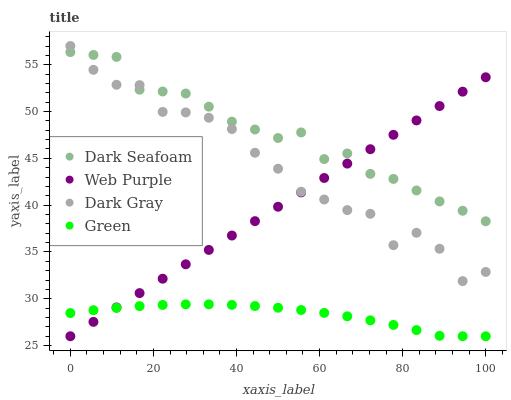Does Green have the minimum area under the curve?
Answer yes or no. Yes. Does Dark Seafoam have the maximum area under the curve?
Answer yes or no. Yes. Does Dark Seafoam have the minimum area under the curve?
Answer yes or no. No. Does Green have the maximum area under the curve?
Answer yes or no. No. Is Web Purple the smoothest?
Answer yes or no. Yes. Is Dark Gray the roughest?
Answer yes or no. Yes. Is Dark Seafoam the smoothest?
Answer yes or no. No. Is Dark Seafoam the roughest?
Answer yes or no. No. Does Green have the lowest value?
Answer yes or no. Yes. Does Dark Seafoam have the lowest value?
Answer yes or no. No. Does Dark Gray have the highest value?
Answer yes or no. Yes. Does Dark Seafoam have the highest value?
Answer yes or no. No. Is Green less than Dark Gray?
Answer yes or no. Yes. Is Dark Seafoam greater than Green?
Answer yes or no. Yes. Does Dark Seafoam intersect Web Purple?
Answer yes or no. Yes. Is Dark Seafoam less than Web Purple?
Answer yes or no. No. Is Dark Seafoam greater than Web Purple?
Answer yes or no. No. Does Green intersect Dark Gray?
Answer yes or no. No. 